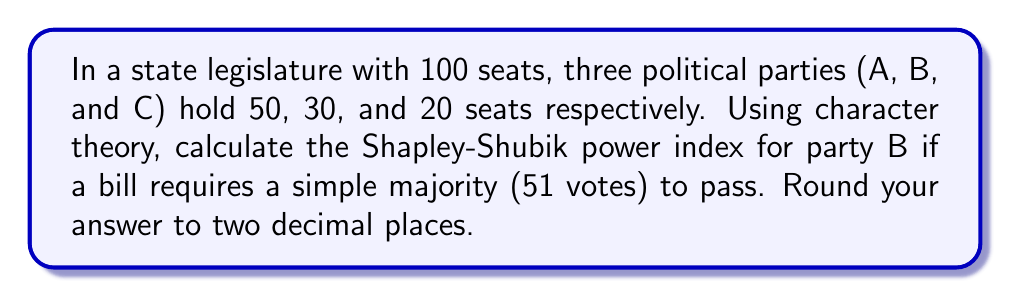Provide a solution to this math problem. To solve this problem using character theory, we'll follow these steps:

1) First, we need to understand that the Shapley-Shubik power index is based on the concept of pivotal voters in all possible orderings of parties.

2) The total number of orderings is 3! = 6.

3) We need to count in how many of these orderings party B is pivotal. A party is pivotal if it changes the coalition from losing to winning.

4) Let's list all possible orderings and check where B is pivotal:
   ABC: B is not pivotal (A already has majority)
   ACB: B is not pivotal (A already has majority)
   BAC: B is pivotal (B+A reaches majority)
   BCA: B is pivotal (B+C doesn't reach majority, but B+C+A does)
   CAB: B is pivotal (C+B reaches majority)
   CBA: B is not pivotal (C+B doesn't reach majority)

5) We see that B is pivotal in 3 out of 6 orderings.

6) The Shapley-Shubik power index is calculated as:
   
   $$ \text{Power Index} = \frac{\text{Number of times party is pivotal}}{\text{Total number of orderings}} $$

7) Plugging in our values:

   $$ \text{Power Index for B} = \frac{3}{6} = 0.5 $$

8) Rounding to two decimal places: 0.50

This result shows that despite having only 30% of the seats, party B has 50% of the voting power in this legislature, highlighting the importance of being a "swing" party in coalition formation.
Answer: 0.50 